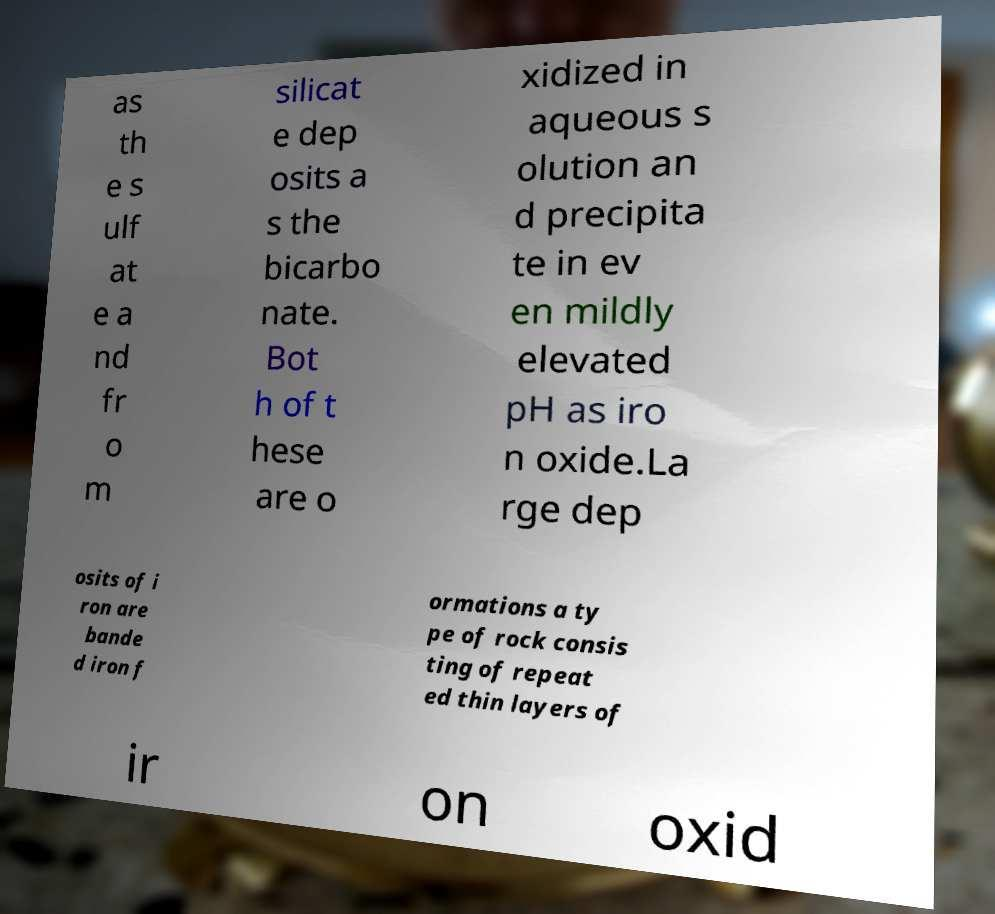There's text embedded in this image that I need extracted. Can you transcribe it verbatim? as th e s ulf at e a nd fr o m silicat e dep osits a s the bicarbo nate. Bot h of t hese are o xidized in aqueous s olution an d precipita te in ev en mildly elevated pH as iro n oxide.La rge dep osits of i ron are bande d iron f ormations a ty pe of rock consis ting of repeat ed thin layers of ir on oxid 